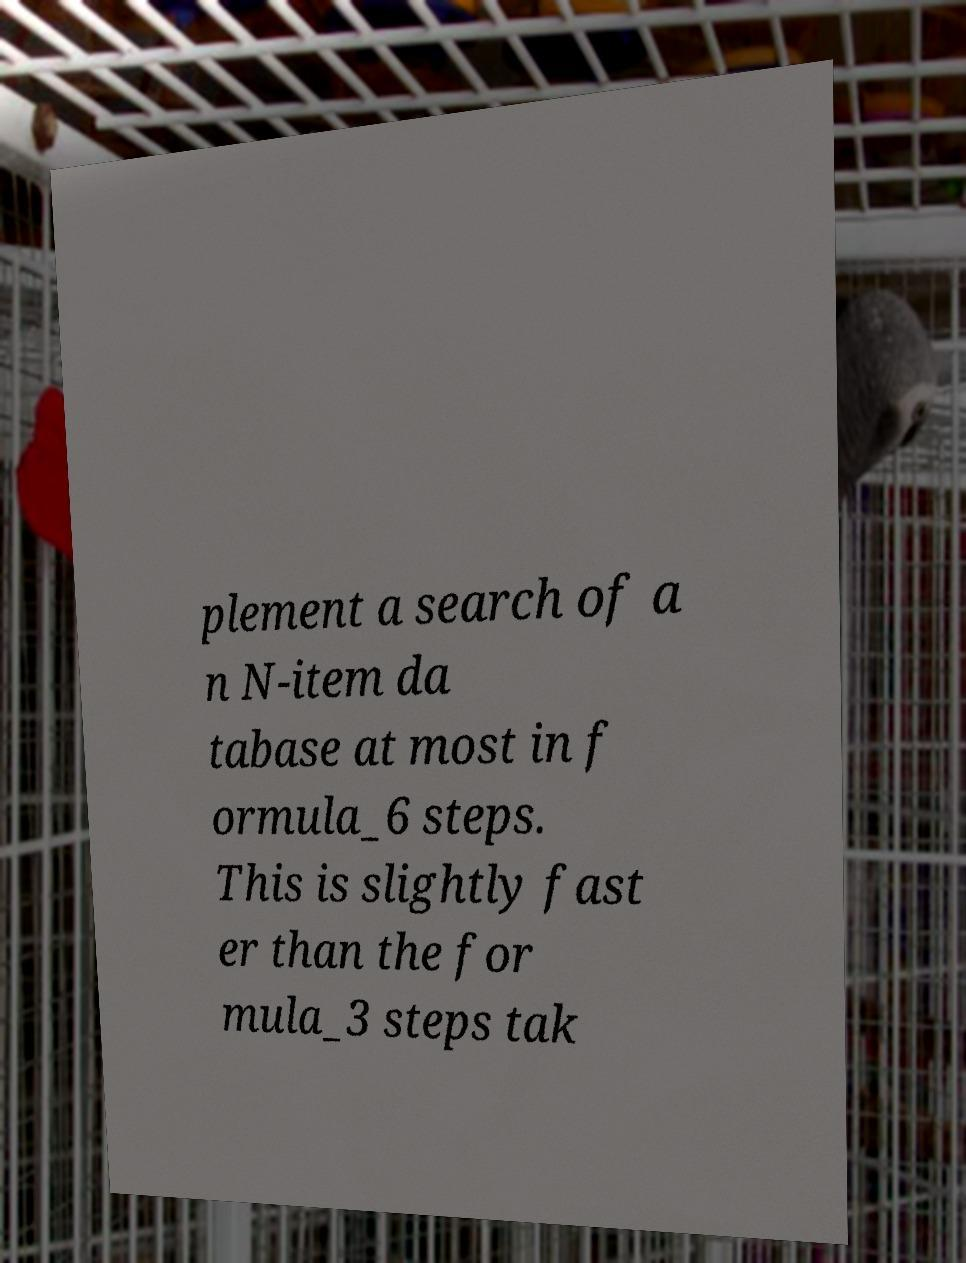For documentation purposes, I need the text within this image transcribed. Could you provide that? plement a search of a n N-item da tabase at most in f ormula_6 steps. This is slightly fast er than the for mula_3 steps tak 